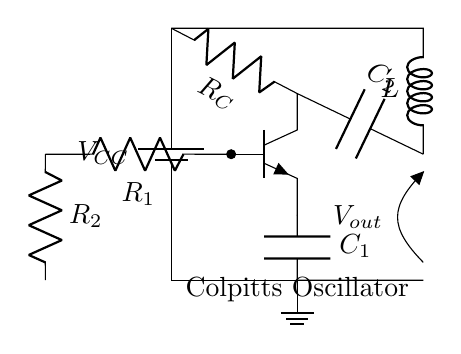What type of oscillator is depicted in the circuit? The circuit diagram clearly indicates that it is a Colpitts oscillator, as indicated by the label in the diagram itself.
Answer: Colpitts oscillator What type of transistor is used in the circuit? The circuit diagram shows an npn transistor symbol, which is the standard representation for an npn transistor in circuit designs.
Answer: npn What components are used for feedback in the Colpitts oscillator? The feedback in this oscillator circuit is provided by the capacitors C1 and C2, as they are a characteristic feature of the Colpitts configuration, forming a voltage divider to control feedback.
Answer: Capacitors C1 and C2 What is the role of the inductor in the circuit? The inductor L integrates into the tank circuit with capacitors C1 and C2, allowing for energy storage and resonance, which is crucial for generating oscillations within the Colpitts oscillator.
Answer: Resonance What is the significance of the resistors R1 and R2 in this circuit? The resistors R1 and R2 set up the biasing conditions for the transistor, enabling it to operate in the active region and effectively amplify the oscillation signal, which is essential for oscillator functionality.
Answer: Biasing the transistor What can be said about the output of the oscillator? The output voltage is designated as Vout, indicating that the oscillatory signal can be extracted from this point in the circuit for further use, such as signal processing or diagnostics.
Answer: Vout 